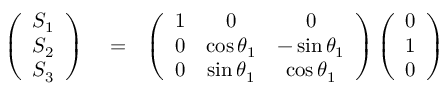Convert formula to latex. <formula><loc_0><loc_0><loc_500><loc_500>\begin{array} { r l r } { \left ( \begin{array} { c } { S _ { 1 } } \\ { S _ { 2 } } \\ { S _ { 3 } } \end{array} \right ) } & = } & { \left ( \begin{array} { c c c } { 1 } & { 0 } & { 0 } \\ { 0 } & { \cos \theta _ { 1 } } & { - \sin \theta _ { 1 } } \\ { 0 } & { \sin \theta _ { 1 } } & { \cos \theta _ { 1 } } \end{array} \right ) \left ( \begin{array} { c } { 0 } \\ { 1 } \\ { 0 } \end{array} \right ) } \end{array}</formula> 